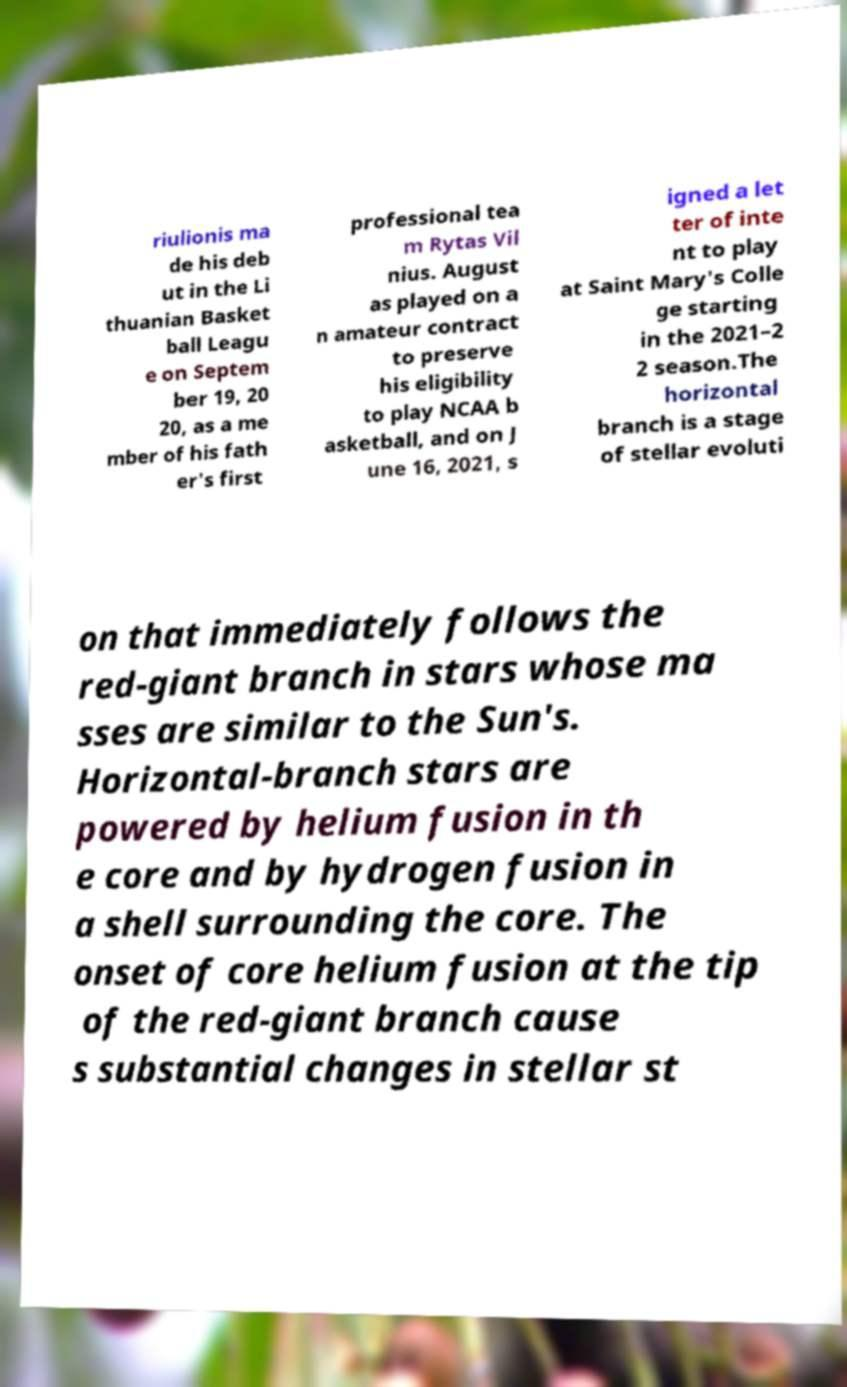Can you read and provide the text displayed in the image?This photo seems to have some interesting text. Can you extract and type it out for me? riulionis ma de his deb ut in the Li thuanian Basket ball Leagu e on Septem ber 19, 20 20, as a me mber of his fath er's first professional tea m Rytas Vil nius. August as played on a n amateur contract to preserve his eligibility to play NCAA b asketball, and on J une 16, 2021, s igned a let ter of inte nt to play at Saint Mary's Colle ge starting in the 2021–2 2 season.The horizontal branch is a stage of stellar evoluti on that immediately follows the red-giant branch in stars whose ma sses are similar to the Sun's. Horizontal-branch stars are powered by helium fusion in th e core and by hydrogen fusion in a shell surrounding the core. The onset of core helium fusion at the tip of the red-giant branch cause s substantial changes in stellar st 